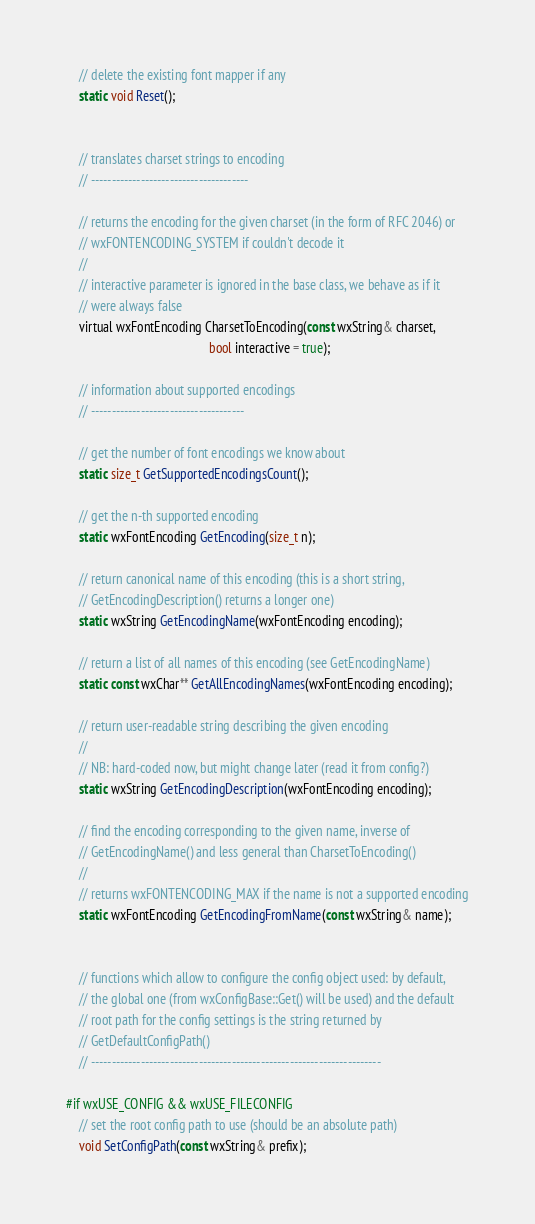Convert code to text. <code><loc_0><loc_0><loc_500><loc_500><_C_>    // delete the existing font mapper if any
    static void Reset();


    // translates charset strings to encoding
    // --------------------------------------

    // returns the encoding for the given charset (in the form of RFC 2046) or
    // wxFONTENCODING_SYSTEM if couldn't decode it
    //
    // interactive parameter is ignored in the base class, we behave as if it
    // were always false
    virtual wxFontEncoding CharsetToEncoding(const wxString& charset,
                                             bool interactive = true);

    // information about supported encodings
    // -------------------------------------

    // get the number of font encodings we know about
    static size_t GetSupportedEncodingsCount();

    // get the n-th supported encoding
    static wxFontEncoding GetEncoding(size_t n);

    // return canonical name of this encoding (this is a short string,
    // GetEncodingDescription() returns a longer one)
    static wxString GetEncodingName(wxFontEncoding encoding);

    // return a list of all names of this encoding (see GetEncodingName)
    static const wxChar** GetAllEncodingNames(wxFontEncoding encoding);

    // return user-readable string describing the given encoding
    //
    // NB: hard-coded now, but might change later (read it from config?)
    static wxString GetEncodingDescription(wxFontEncoding encoding);

    // find the encoding corresponding to the given name, inverse of
    // GetEncodingName() and less general than CharsetToEncoding()
    //
    // returns wxFONTENCODING_MAX if the name is not a supported encoding
    static wxFontEncoding GetEncodingFromName(const wxString& name);


    // functions which allow to configure the config object used: by default,
    // the global one (from wxConfigBase::Get() will be used) and the default
    // root path for the config settings is the string returned by
    // GetDefaultConfigPath()
    // ----------------------------------------------------------------------

#if wxUSE_CONFIG && wxUSE_FILECONFIG
    // set the root config path to use (should be an absolute path)
    void SetConfigPath(const wxString& prefix);
</code> 